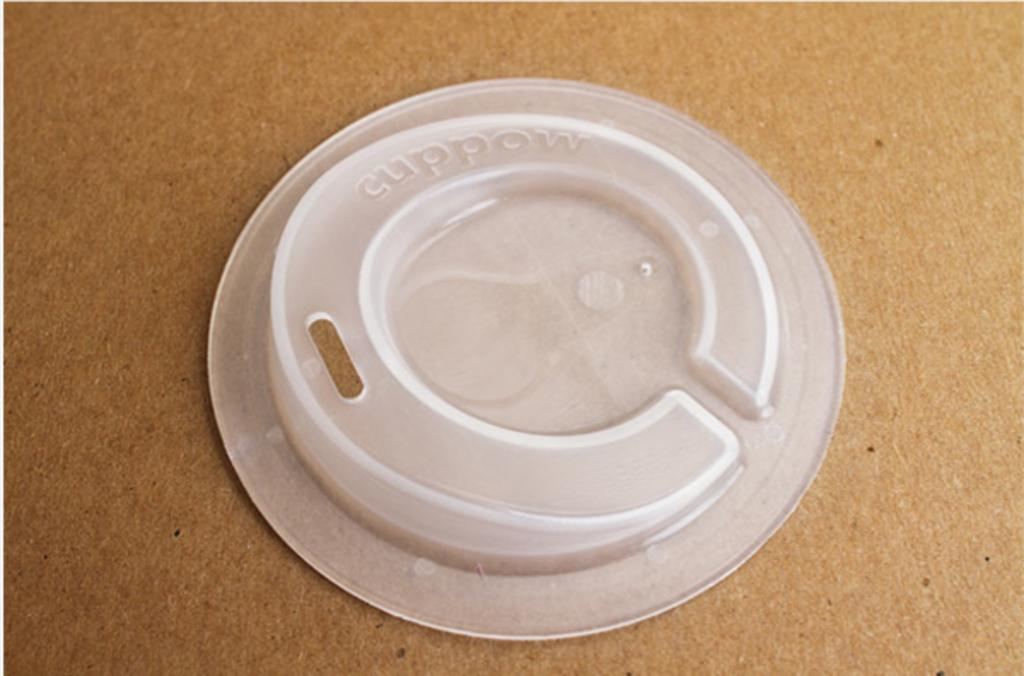What is the color of the object in the image? The object in the image is white-colored. What is written or printed on the object? The object has text on it. On what type of surface is the object placed? The object is on a wooden surface. Are there any bushes growing around the object in the image? There is no mention of bushes in the provided facts, so we cannot determine if there are any bushes around the object in the image. How does the object aid in the digestion process? The provided facts do not mention any digestion-related function of the object, so we cannot determine how it aids in the digestion process. 